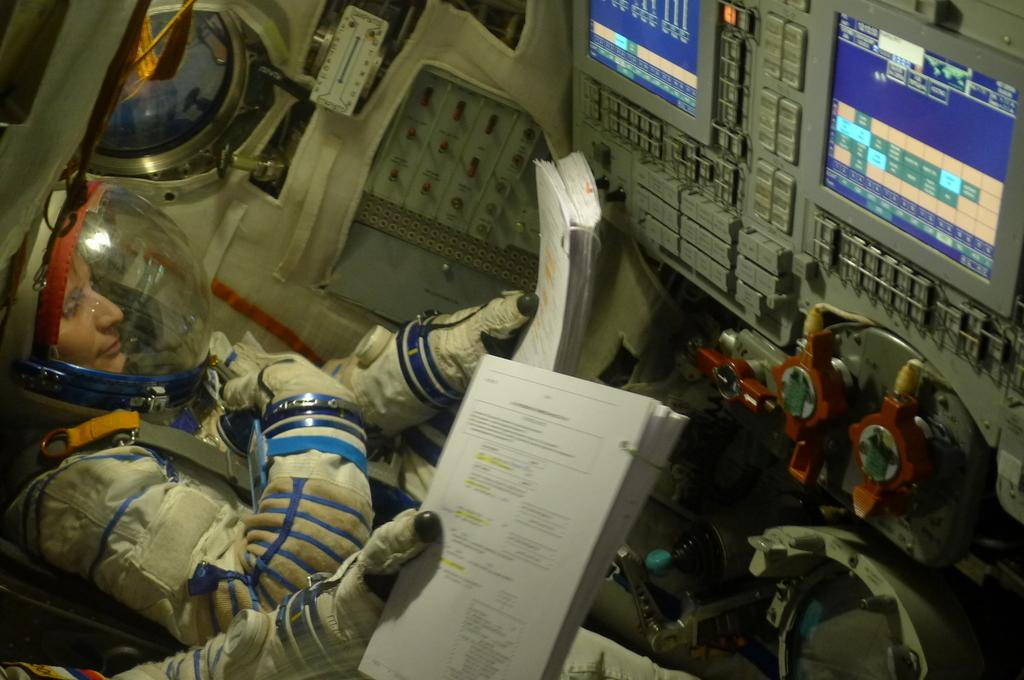What type of characters are present in the image? There are spacemen in the image. What are the spacemen holding in their hands? The spacemen are holding books. What objects can be seen in front of the spacemen? There are machines in front of the spacemen. How does the hen interact with the spacemen in the image? There is no hen present in the image, so it cannot interact with the spacemen. 